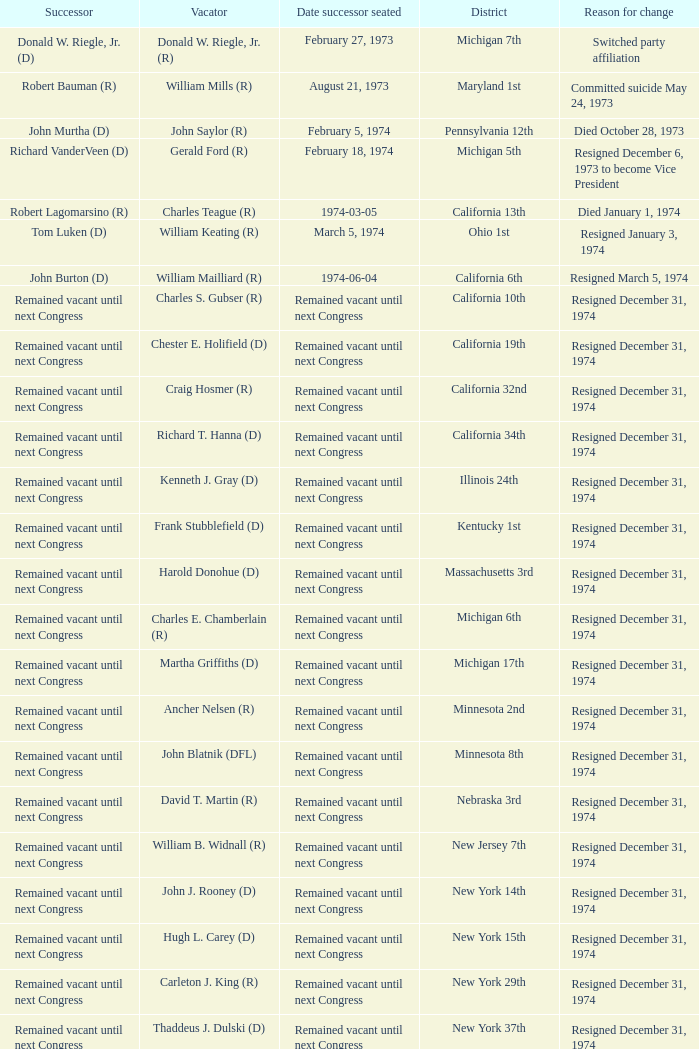Parse the full table. {'header': ['Successor', 'Vacator', 'Date successor seated', 'District', 'Reason for change'], 'rows': [['Donald W. Riegle, Jr. (D)', 'Donald W. Riegle, Jr. (R)', 'February 27, 1973', 'Michigan 7th', 'Switched party affiliation'], ['Robert Bauman (R)', 'William Mills (R)', 'August 21, 1973', 'Maryland 1st', 'Committed suicide May 24, 1973'], ['John Murtha (D)', 'John Saylor (R)', 'February 5, 1974', 'Pennsylvania 12th', 'Died October 28, 1973'], ['Richard VanderVeen (D)', 'Gerald Ford (R)', 'February 18, 1974', 'Michigan 5th', 'Resigned December 6, 1973 to become Vice President'], ['Robert Lagomarsino (R)', 'Charles Teague (R)', '1974-03-05', 'California 13th', 'Died January 1, 1974'], ['Tom Luken (D)', 'William Keating (R)', 'March 5, 1974', 'Ohio 1st', 'Resigned January 3, 1974'], ['John Burton (D)', 'William Mailliard (R)', '1974-06-04', 'California 6th', 'Resigned March 5, 1974'], ['Remained vacant until next Congress', 'Charles S. Gubser (R)', 'Remained vacant until next Congress', 'California 10th', 'Resigned December 31, 1974'], ['Remained vacant until next Congress', 'Chester E. Holifield (D)', 'Remained vacant until next Congress', 'California 19th', 'Resigned December 31, 1974'], ['Remained vacant until next Congress', 'Craig Hosmer (R)', 'Remained vacant until next Congress', 'California 32nd', 'Resigned December 31, 1974'], ['Remained vacant until next Congress', 'Richard T. Hanna (D)', 'Remained vacant until next Congress', 'California 34th', 'Resigned December 31, 1974'], ['Remained vacant until next Congress', 'Kenneth J. Gray (D)', 'Remained vacant until next Congress', 'Illinois 24th', 'Resigned December 31, 1974'], ['Remained vacant until next Congress', 'Frank Stubblefield (D)', 'Remained vacant until next Congress', 'Kentucky 1st', 'Resigned December 31, 1974'], ['Remained vacant until next Congress', 'Harold Donohue (D)', 'Remained vacant until next Congress', 'Massachusetts 3rd', 'Resigned December 31, 1974'], ['Remained vacant until next Congress', 'Charles E. Chamberlain (R)', 'Remained vacant until next Congress', 'Michigan 6th', 'Resigned December 31, 1974'], ['Remained vacant until next Congress', 'Martha Griffiths (D)', 'Remained vacant until next Congress', 'Michigan 17th', 'Resigned December 31, 1974'], ['Remained vacant until next Congress', 'Ancher Nelsen (R)', 'Remained vacant until next Congress', 'Minnesota 2nd', 'Resigned December 31, 1974'], ['Remained vacant until next Congress', 'John Blatnik (DFL)', 'Remained vacant until next Congress', 'Minnesota 8th', 'Resigned December 31, 1974'], ['Remained vacant until next Congress', 'David T. Martin (R)', 'Remained vacant until next Congress', 'Nebraska 3rd', 'Resigned December 31, 1974'], ['Remained vacant until next Congress', 'William B. Widnall (R)', 'Remained vacant until next Congress', 'New Jersey 7th', 'Resigned December 31, 1974'], ['Remained vacant until next Congress', 'John J. Rooney (D)', 'Remained vacant until next Congress', 'New York 14th', 'Resigned December 31, 1974'], ['Remained vacant until next Congress', 'Hugh L. Carey (D)', 'Remained vacant until next Congress', 'New York 15th', 'Resigned December 31, 1974'], ['Remained vacant until next Congress', 'Carleton J. King (R)', 'Remained vacant until next Congress', 'New York 29th', 'Resigned December 31, 1974'], ['Remained vacant until next Congress', 'Thaddeus J. Dulski (D)', 'Remained vacant until next Congress', 'New York 37th', 'Resigned December 31, 1974'], ['Remained vacant until next Congress', 'William Minshall (R)', 'Remained vacant until next Congress', 'Ohio 23rd', 'Resigned December 31, 1974'], ['Remained vacant until next Congress', 'Edith S. Green (D)', 'Remained vacant until next Congress', 'Oregon 3rd', 'Resigned December 31, 1974'], ['Remained vacant until next Congress', 'Frank M. Clark (D)', 'Remained vacant until next Congress', 'Pennsylvania 25th', 'Resigned December 31, 1974'], ['Remained vacant until next Congress', 'W.J. Bryan Dorn (D)', 'Remained vacant until next Congress', 'South Carolina 3rd', 'Resigned December 31, 1974'], ['Remained vacant until next Congress', 'Thomas S. Gettys (D)', 'Remained vacant until next Congress', 'South Carolina 5th', 'Resigned December 31, 1974'], ['Remained vacant until next Congress', 'O. C. Fisher (D)', 'Remained vacant until next Congress', 'Texas 21st', 'Resigned December 31, 1974'], ['Remained vacant until next Congress', 'Julia B. Hansen (D)', 'Remained vacant until next Congress', 'Washington 3rd', 'Resigned December 31, 1974'], ['Remained vacant until next Congress', 'Vernon W. Thomson (R)', 'Remained vacant until next Congress', 'Wisconsin 3rd', 'Resigned December 31, 1974']]} Who was the vacator when the date successor seated was august 21, 1973? William Mills (R). 